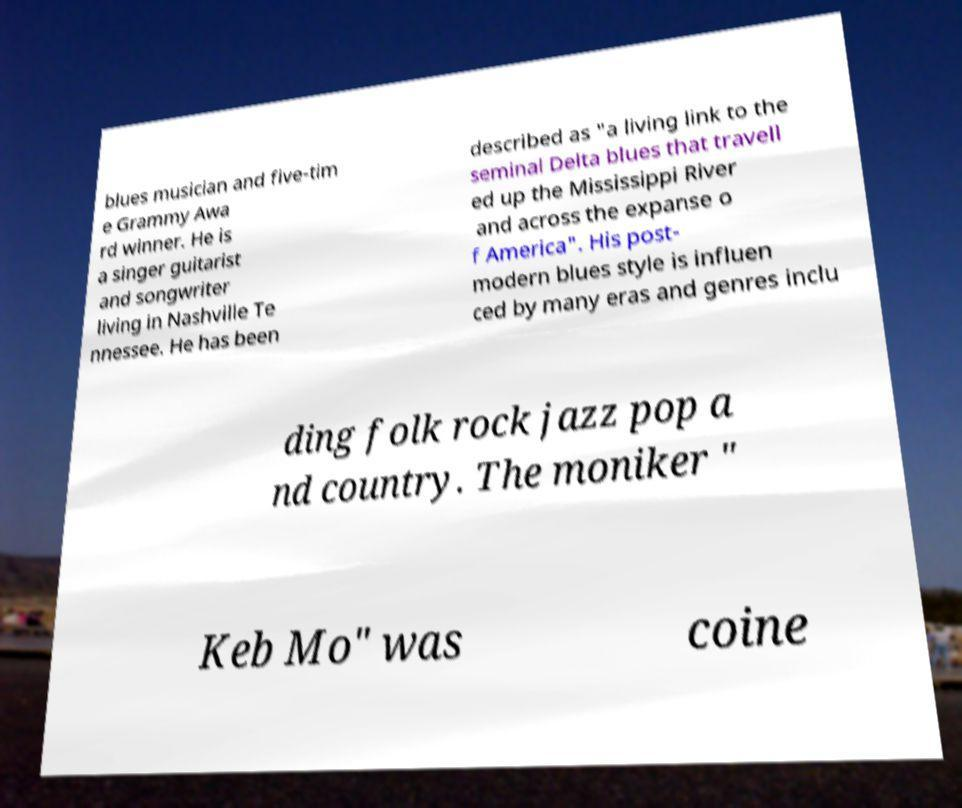There's text embedded in this image that I need extracted. Can you transcribe it verbatim? blues musician and five-tim e Grammy Awa rd winner. He is a singer guitarist and songwriter living in Nashville Te nnessee. He has been described as "a living link to the seminal Delta blues that travell ed up the Mississippi River and across the expanse o f America". His post- modern blues style is influen ced by many eras and genres inclu ding folk rock jazz pop a nd country. The moniker " Keb Mo" was coine 